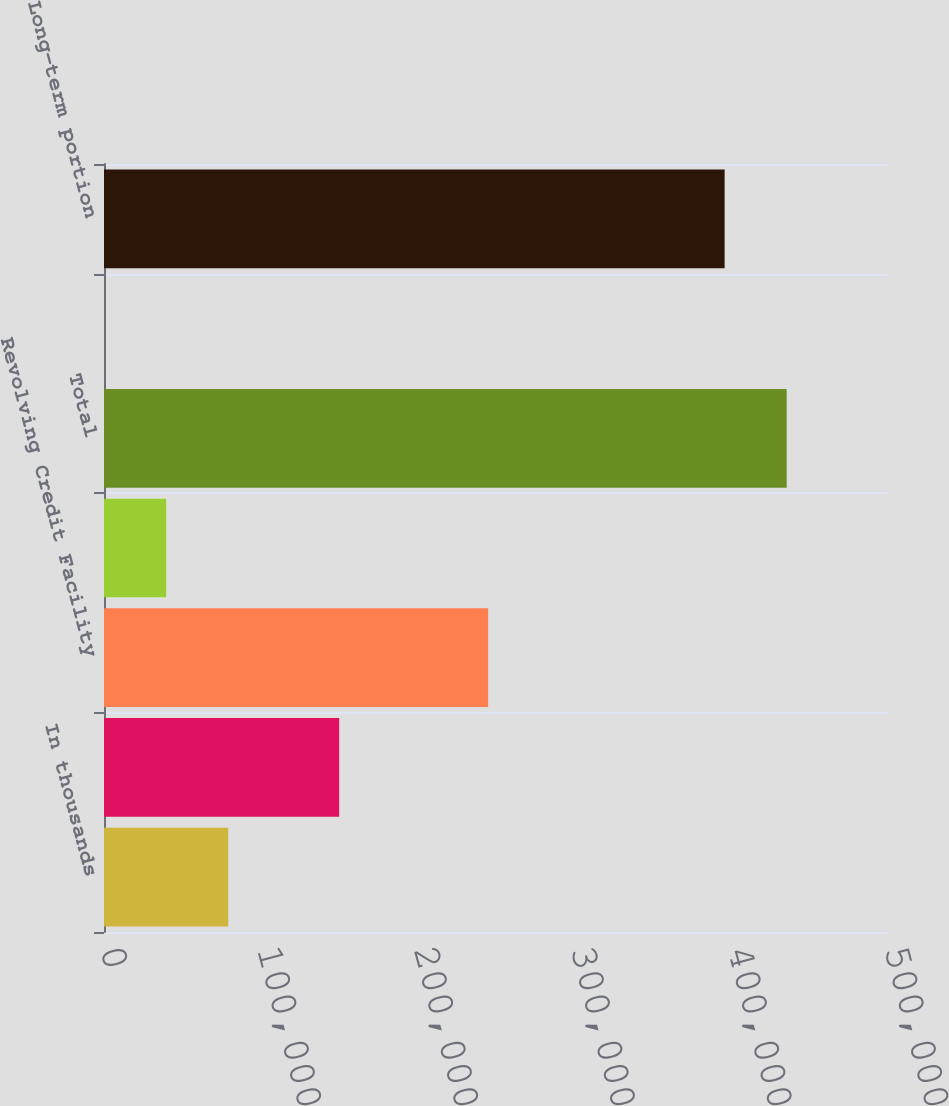Convert chart to OTSL. <chart><loc_0><loc_0><loc_500><loc_500><bar_chart><fcel>In thousands<fcel>6875 senior notes due 2013<fcel>Revolving Credit Facility<fcel>Capital Leases<fcel>Total<fcel>Less-current portion<fcel>Long-term portion<nl><fcel>79229<fcel>150000<fcel>245000<fcel>39648.5<fcel>435386<fcel>68<fcel>395805<nl></chart> 